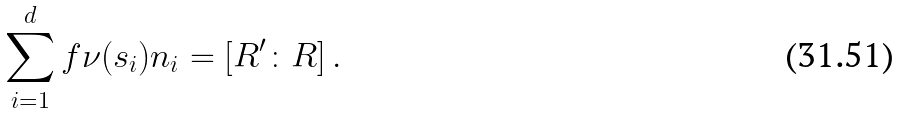Convert formula to latex. <formula><loc_0><loc_0><loc_500><loc_500>\sum _ { i = 1 } ^ { d } f \nu ( s _ { i } ) n _ { i } = [ R ^ { \prime } \colon R ] \, .</formula> 